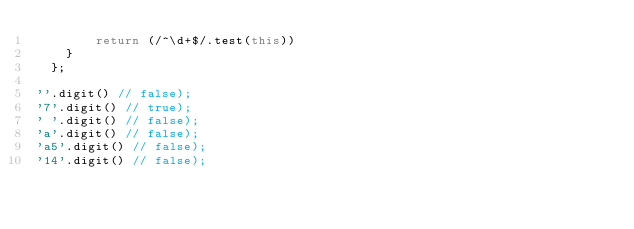Convert code to text. <code><loc_0><loc_0><loc_500><loc_500><_JavaScript_>        return (/^\d+$/.test(this))
    }
  };

''.digit() // false);
'7'.digit() // true);
' '.digit() // false);
'a'.digit() // false);
'a5'.digit() // false);
'14'.digit() // false);
</code> 